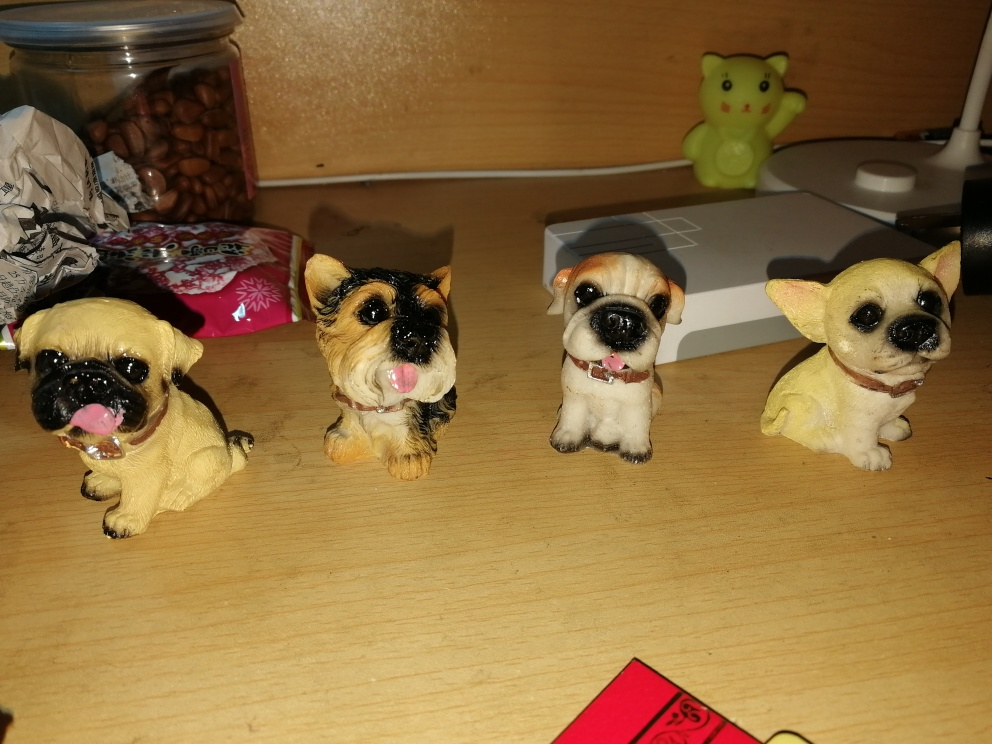What can be seen as the subject in this image? The image features a delightful display of four small dog figurines, each modeled with its own unique pose and coloration, likely designed to capture the charming essence of different dog breeds. 